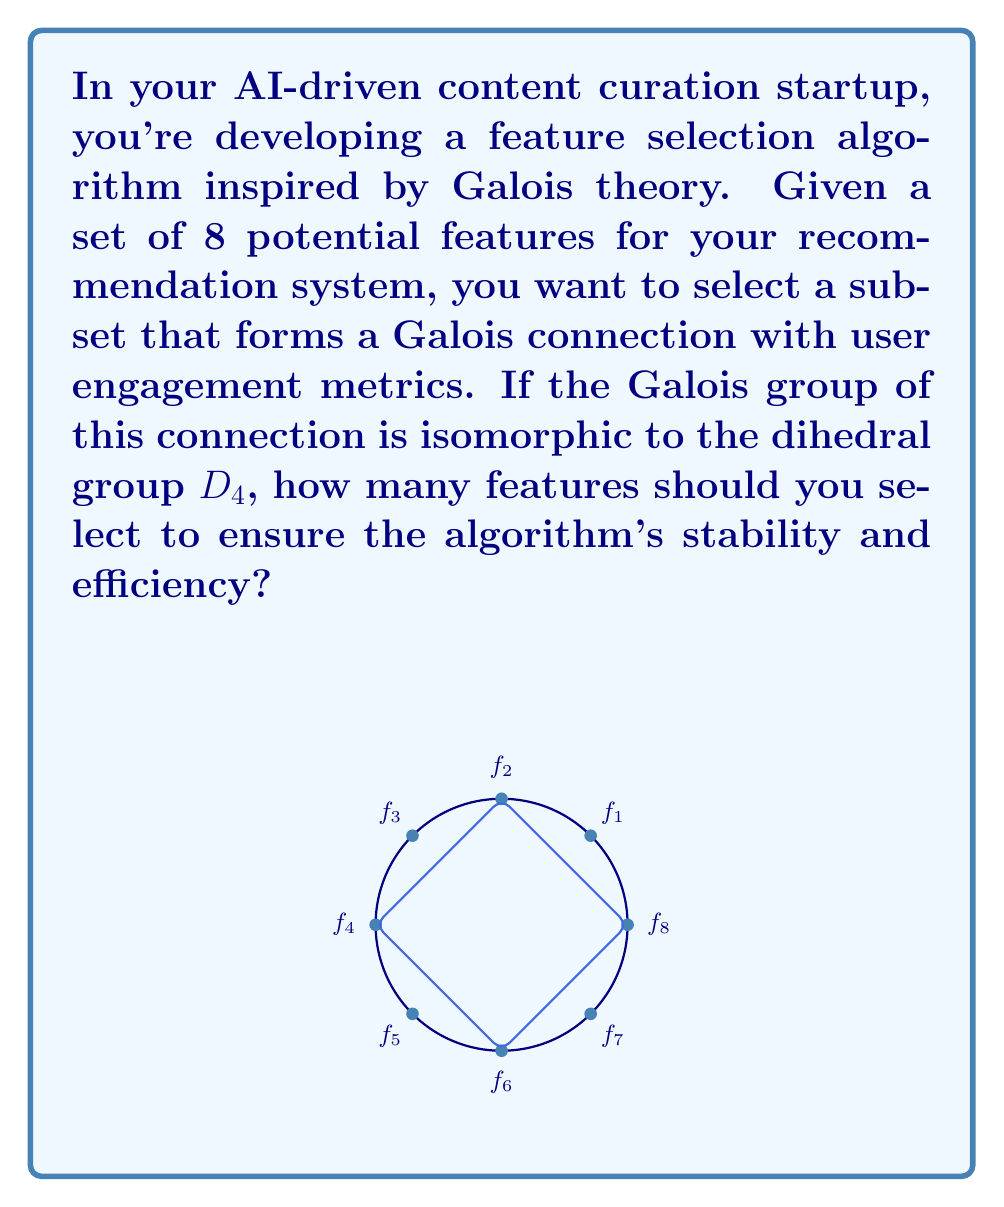Can you answer this question? Let's approach this step-by-step:

1) First, recall that a Galois connection is a pair of functions between two partially ordered sets that satisfies certain properties. In this context, we're looking at the connection between feature subsets and user engagement metrics.

2) The Galois group of this connection is isomorphic to $D_4$, the dihedral group of order 8. This group represents the symmetries of a square.

3) $D_4$ has 5 subgroups: 
   - The trivial subgroup {e}
   - The whole group $D_4$
   - Three subgroups of order 2
   - One subgroup of order 4

4) In Galois theory, there's a fundamental theorem that establishes a bijection between intermediate fields of a field extension and subgroups of the Galois group.

5) Translating this to our feature selection problem, the subgroups of $D_4$ correspond to stable feature subsets.

6) We want to select a feature subset that ensures stability and efficiency. The subgroup of order 4 (which corresponds to the rotations of the square) provides a good balance between these criteria.

7) The subgroup of order 4 in $D_4$ corresponds to selecting half of the total features.

8) Since we have 8 total features, selecting half would mean choosing 4 features.

Therefore, to ensure stability and efficiency in your algorithm, you should select 4 features out of the 8 potential features.
Answer: 4 features 